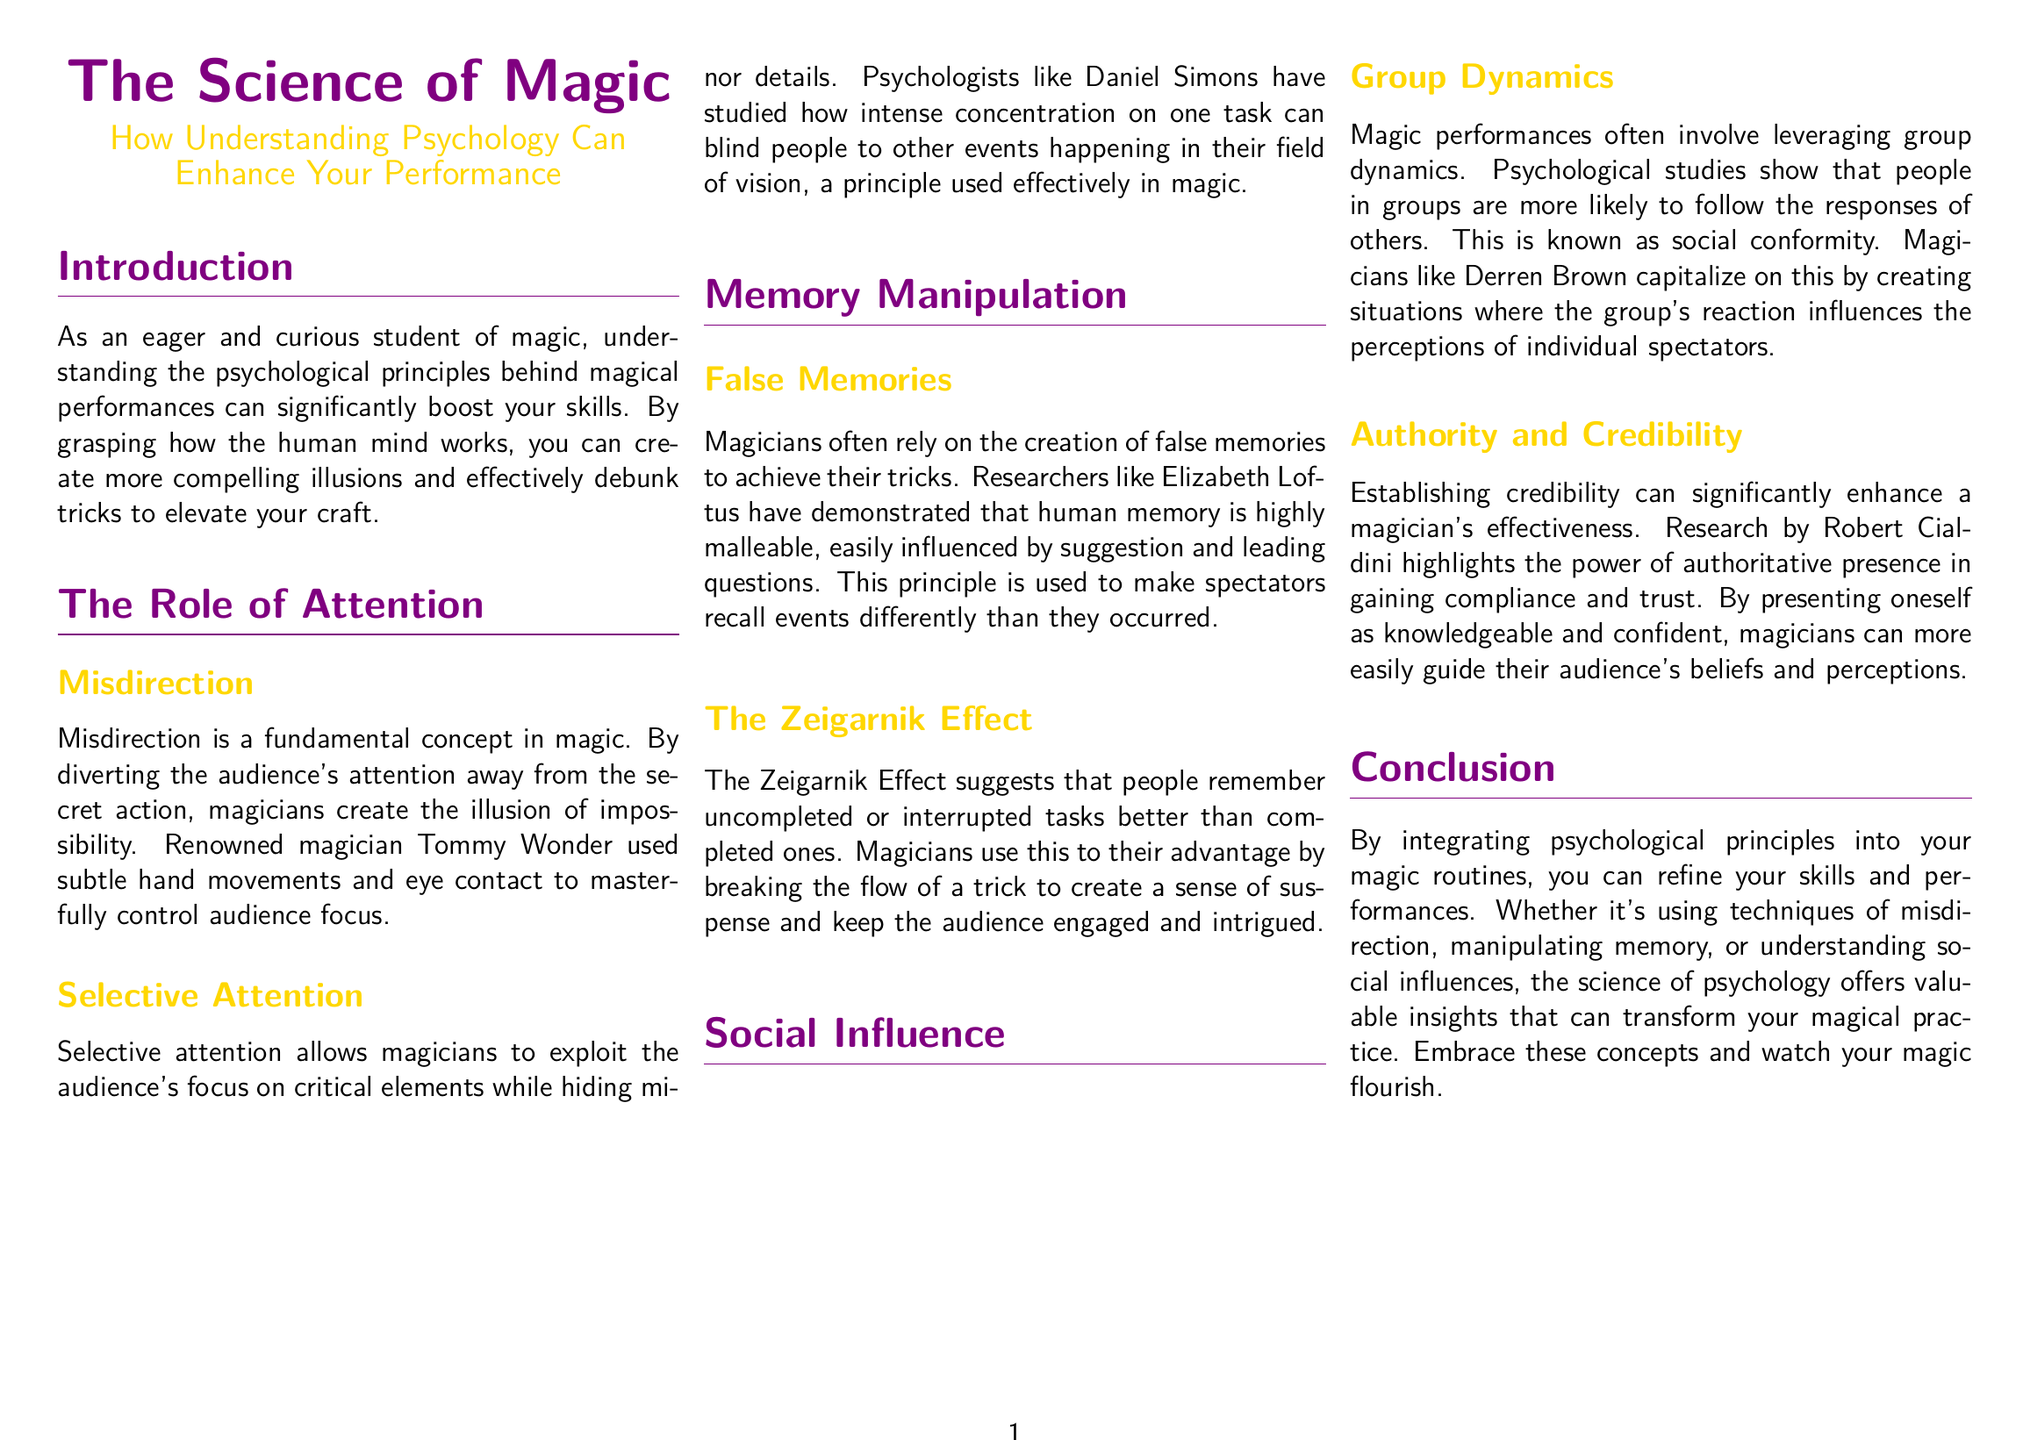What is the title of the document? The title is prominently displayed at the top of the document, reflecting the main subject matter.
Answer: The Science of Magic Who is a renowned magician mentioned for using misdirection? The document specifically names a well-known magician as an example of effective misdirection techniques.
Answer: Tommy Wonder What principle suggests that people remember uncompleted tasks better? The document discusses a psychological principle that emphasizes the retention of interrupted tasks, which is crucial for maintaining audience interest.
Answer: The Zeigarnik Effect Which psychologist studied selective attention? The document references a psychologist known for research in the area of attention, linking it to magic performance techniques.
Answer: Daniel Simons What is the color code for the magic gold mentioned in the document? The document provides a specific color code for one of the design elements that align with the theme of magic.
Answer: RGB 255,215,0 What effect does social conformity have in magic performances? The document explains the relevance of social dynamics in enhancing the magician's performance by aligning audience reactions.
Answer: Group Dynamics 